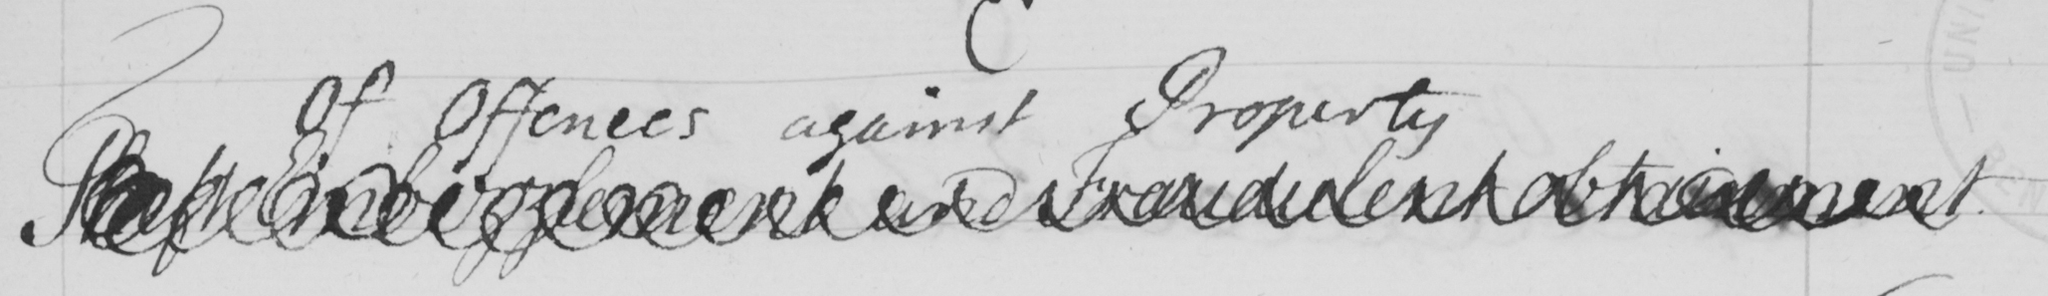Can you tell me what this handwritten text says? Theft Embezzlement and Fraudulent obtainment . 